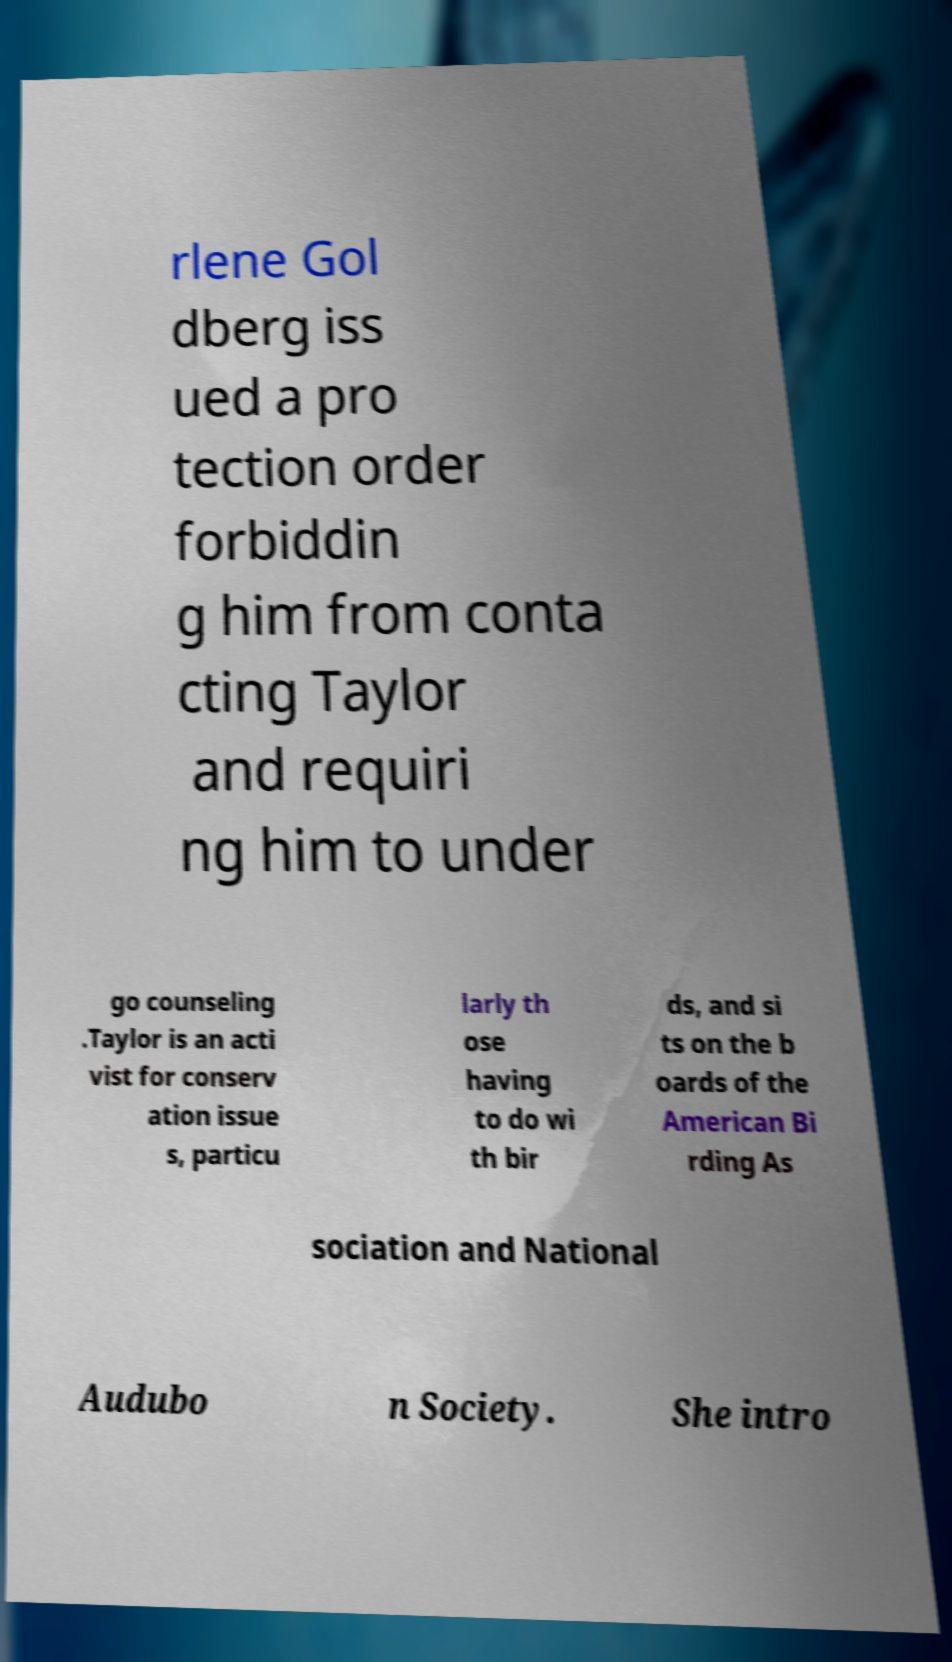For documentation purposes, I need the text within this image transcribed. Could you provide that? rlene Gol dberg iss ued a pro tection order forbiddin g him from conta cting Taylor and requiri ng him to under go counseling .Taylor is an acti vist for conserv ation issue s, particu larly th ose having to do wi th bir ds, and si ts on the b oards of the American Bi rding As sociation and National Audubo n Society. She intro 